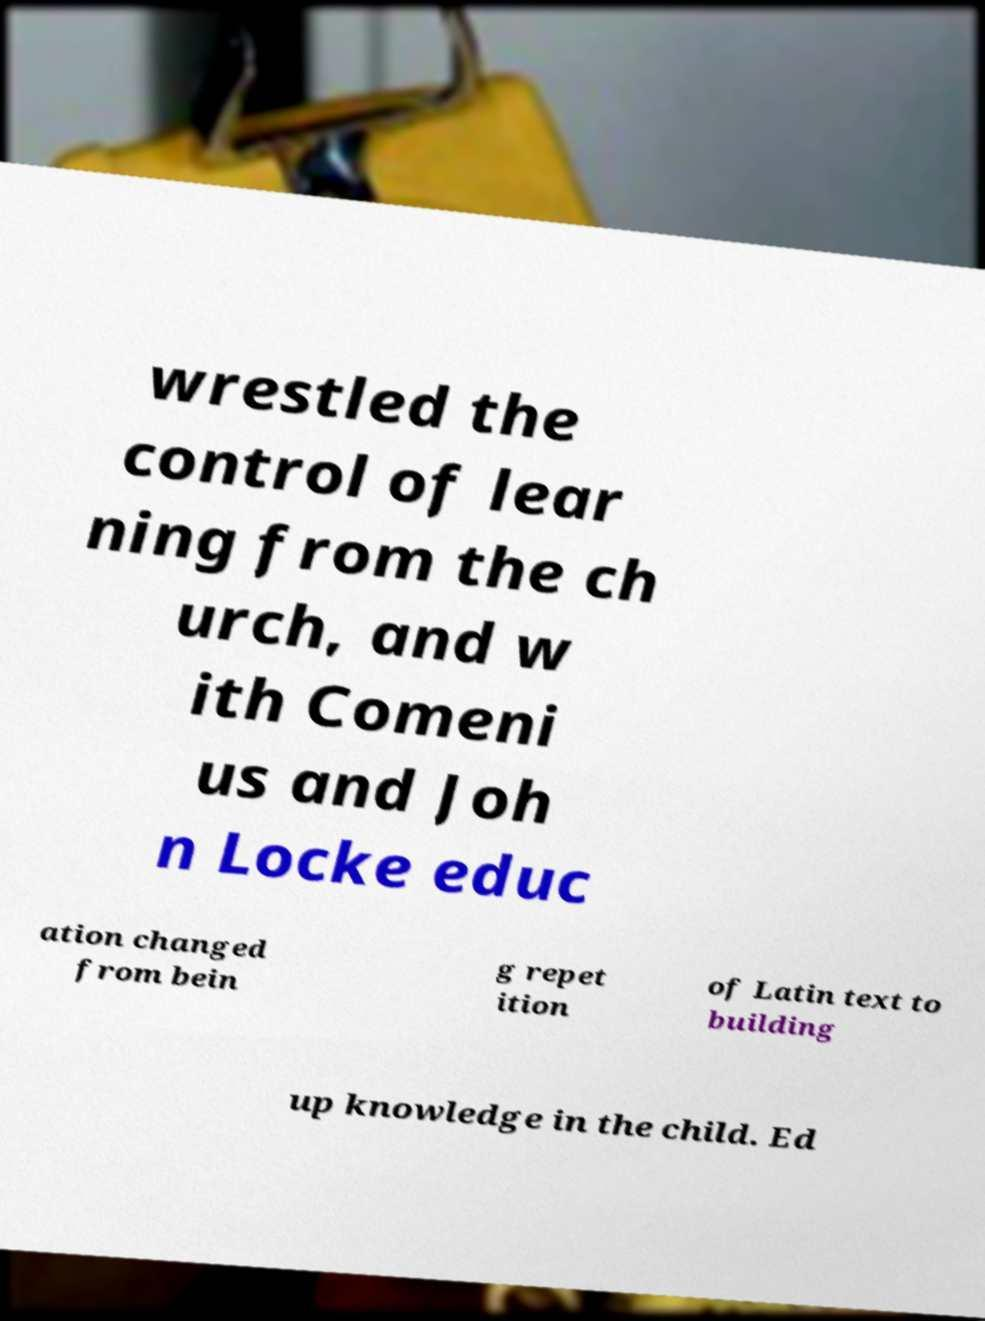There's text embedded in this image that I need extracted. Can you transcribe it verbatim? wrestled the control of lear ning from the ch urch, and w ith Comeni us and Joh n Locke educ ation changed from bein g repet ition of Latin text to building up knowledge in the child. Ed 